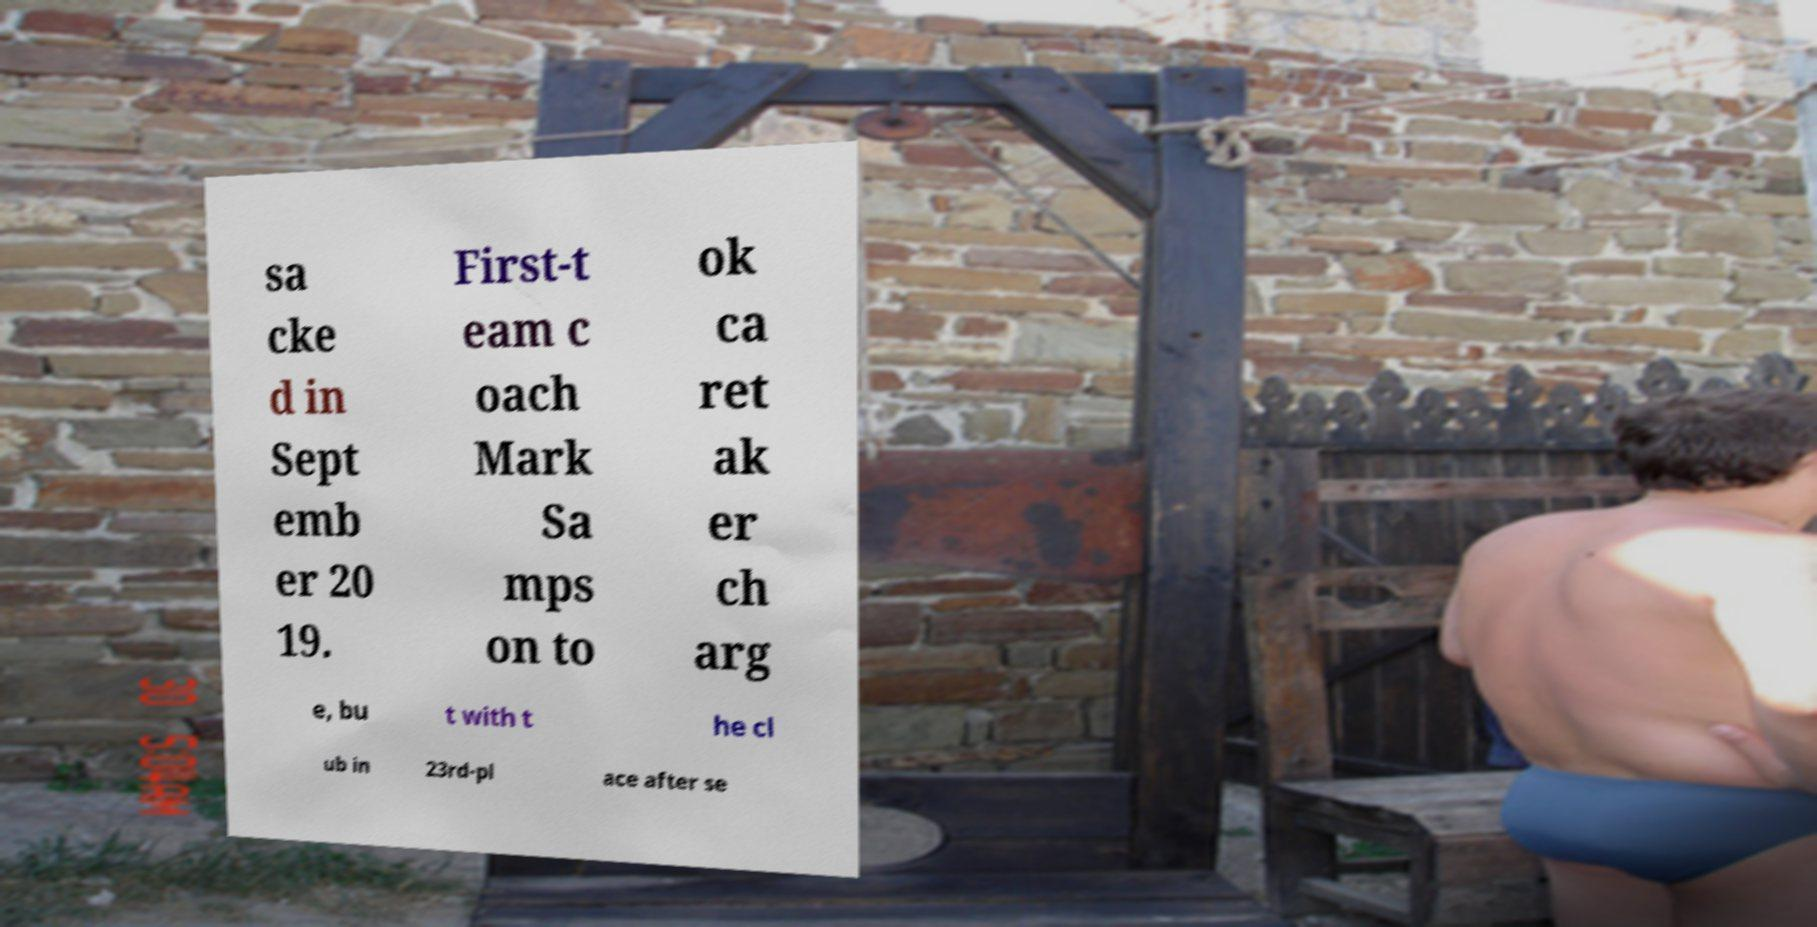There's text embedded in this image that I need extracted. Can you transcribe it verbatim? sa cke d in Sept emb er 20 19. First-t eam c oach Mark Sa mps on to ok ca ret ak er ch arg e, bu t with t he cl ub in 23rd-pl ace after se 